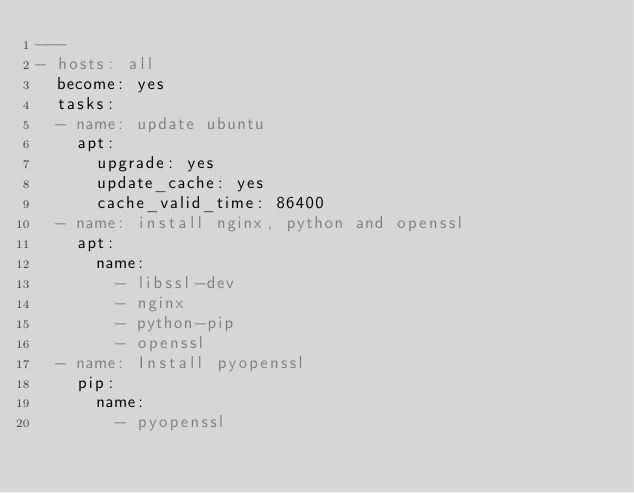Convert code to text. <code><loc_0><loc_0><loc_500><loc_500><_YAML_>---
- hosts: all
  become: yes
  tasks:
  - name: update ubuntu
    apt:
      upgrade: yes
      update_cache: yes
      cache_valid_time: 86400
  - name: install nginx, python and openssl
    apt:
      name:
        - libssl-dev
        - nginx
        - python-pip
        - openssl
  - name: Install pyopenssl
    pip:
      name:
        - pyopenssl</code> 